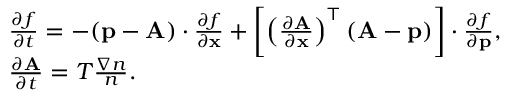<formula> <loc_0><loc_0><loc_500><loc_500>\begin{array} { r l } & { \frac { \partial f } { \partial t } = - ( { \mathbf p } - { \mathbf A } ) \cdot \frac { \partial f } { \partial { \mathbf x } } + \left [ \left ( \frac { \partial { \mathbf A } } { \partial \mathbf x } \right ) ^ { \top } ( { \mathbf A } - { \mathbf p } ) \right ] \cdot \frac { \partial f } { \partial { \mathbf p } } , } \\ & { \frac { \partial { \mathbf A } } { \partial t } = T \frac { \nabla n } { n } . } \end{array}</formula> 